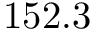Convert formula to latex. <formula><loc_0><loc_0><loc_500><loc_500>1 5 2 . 3</formula> 